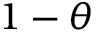<formula> <loc_0><loc_0><loc_500><loc_500>1 - \theta</formula> 